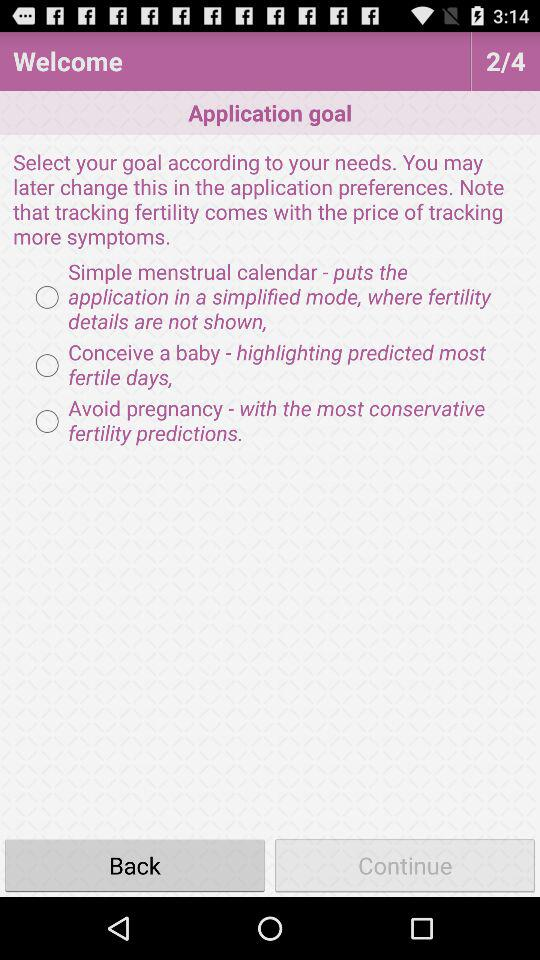How many options are there for the application goal?
Answer the question using a single word or phrase. 3 